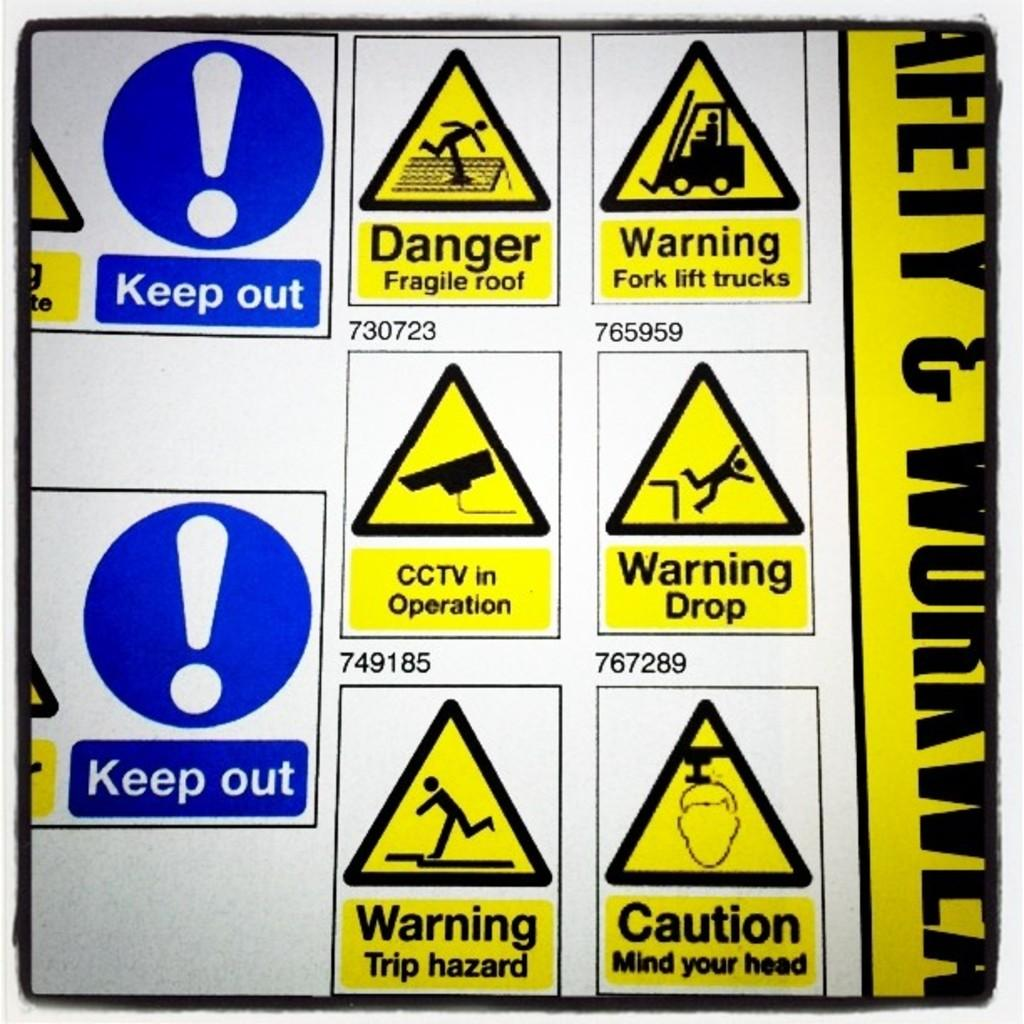What can be seen in the image that provides information or directions? There are signs in the image. What is the color of the signs? The signs are yellow in color. What is written on the signs? There is writing on the signs. What type of machine is depicted on the signs in the image? There is no machine depicted on the signs in the image; the signs are yellow with writing on them. 